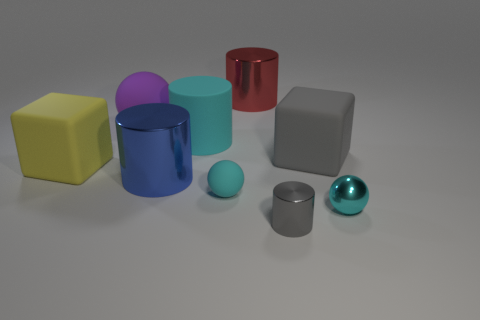Add 1 big brown metallic balls. How many objects exist? 10 Subtract all matte spheres. How many spheres are left? 1 Subtract all green cylinders. How many cyan balls are left? 2 Subtract 2 cubes. How many cubes are left? 0 Subtract all balls. How many objects are left? 6 Subtract all gray cubes. How many cubes are left? 1 Add 1 metallic cylinders. How many metallic cylinders are left? 4 Add 8 blue things. How many blue things exist? 9 Subtract 0 blue spheres. How many objects are left? 9 Subtract all red blocks. Subtract all yellow cylinders. How many blocks are left? 2 